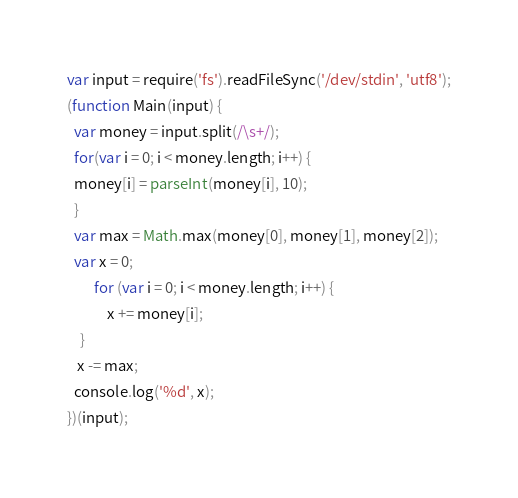Convert code to text. <code><loc_0><loc_0><loc_500><loc_500><_JavaScript_>var input = require('fs').readFileSync('/dev/stdin', 'utf8');
(function Main(input) {
  var money = input.split(/\s+/);
  for(var i = 0; i < money.length; i++) {
  money[i] = parseInt(money[i], 10);
  }
  var max = Math.max(money[0], money[1], money[2]); 
  var x = 0;
		for (var i = 0; i < money.length; i++) {
			x += money[i];
    }
   x -= max; 
  console.log('%d', x);
})(input);
</code> 